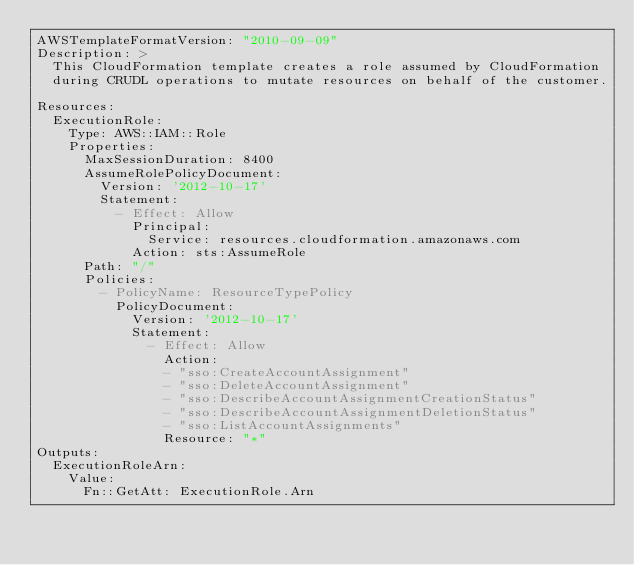Convert code to text. <code><loc_0><loc_0><loc_500><loc_500><_YAML_>AWSTemplateFormatVersion: "2010-09-09"
Description: >
  This CloudFormation template creates a role assumed by CloudFormation
  during CRUDL operations to mutate resources on behalf of the customer.

Resources:
  ExecutionRole:
    Type: AWS::IAM::Role
    Properties:
      MaxSessionDuration: 8400
      AssumeRolePolicyDocument:
        Version: '2012-10-17'
        Statement:
          - Effect: Allow
            Principal:
              Service: resources.cloudformation.amazonaws.com
            Action: sts:AssumeRole
      Path: "/"
      Policies:
        - PolicyName: ResourceTypePolicy
          PolicyDocument:
            Version: '2012-10-17'
            Statement:
              - Effect: Allow
                Action:
                - "sso:CreateAccountAssignment"
                - "sso:DeleteAccountAssignment"
                - "sso:DescribeAccountAssignmentCreationStatus"
                - "sso:DescribeAccountAssignmentDeletionStatus"
                - "sso:ListAccountAssignments"
                Resource: "*"
Outputs:
  ExecutionRoleArn:
    Value:
      Fn::GetAtt: ExecutionRole.Arn
</code> 